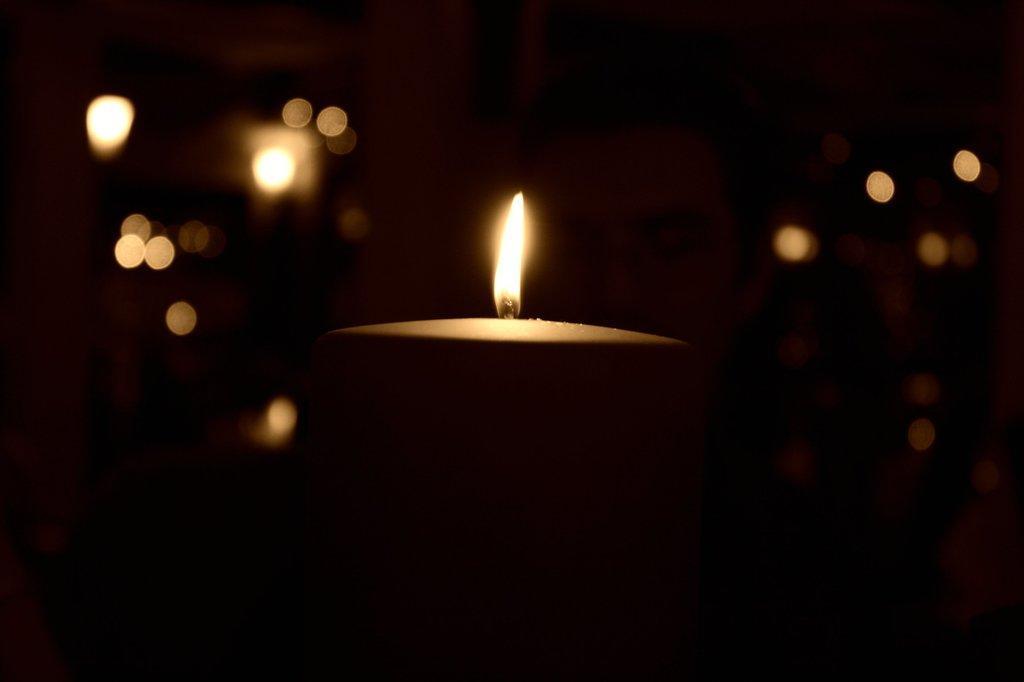Could you give a brief overview of what you see in this image? As we can see in the image in the front there is a candle and the image is little dark. 